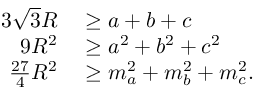Convert formula to latex. <formula><loc_0><loc_0><loc_500><loc_500>\begin{array} { r l } { 3 { \sqrt { 3 } } R } & \geq a + b + c } \\ { 9 R ^ { 2 } } & \geq a ^ { 2 } + b ^ { 2 } + c ^ { 2 } } \\ { { \frac { 2 7 } { 4 } } R ^ { 2 } } & \geq m _ { a } ^ { 2 } + m _ { b } ^ { 2 } + m _ { c } ^ { 2 } . } \end{array}</formula> 